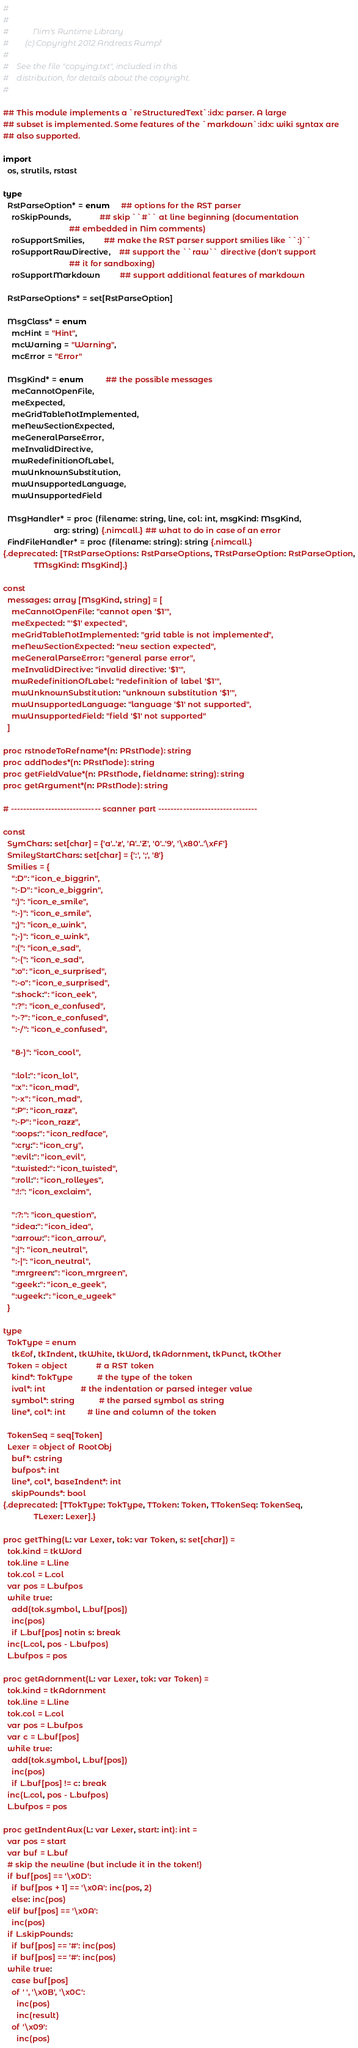<code> <loc_0><loc_0><loc_500><loc_500><_Nim_>#
#
#            Nim's Runtime Library
#        (c) Copyright 2012 Andreas Rumpf
#
#    See the file "copying.txt", included in this
#    distribution, for details about the copyright.
#

## This module implements a `reStructuredText`:idx: parser. A large
## subset is implemented. Some features of the `markdown`:idx: wiki syntax are
## also supported.

import
  os, strutils, rstast

type
  RstParseOption* = enum     ## options for the RST parser
    roSkipPounds,             ## skip ``#`` at line beginning (documentation
                              ## embedded in Nim comments)
    roSupportSmilies,         ## make the RST parser support smilies like ``:)``
    roSupportRawDirective,    ## support the ``raw`` directive (don't support
                              ## it for sandboxing)
    roSupportMarkdown         ## support additional features of markdown

  RstParseOptions* = set[RstParseOption]

  MsgClass* = enum
    mcHint = "Hint",
    mcWarning = "Warning",
    mcError = "Error"

  MsgKind* = enum          ## the possible messages
    meCannotOpenFile,
    meExpected,
    meGridTableNotImplemented,
    meNewSectionExpected,
    meGeneralParseError,
    meInvalidDirective,
    mwRedefinitionOfLabel,
    mwUnknownSubstitution,
    mwUnsupportedLanguage,
    mwUnsupportedField

  MsgHandler* = proc (filename: string, line, col: int, msgKind: MsgKind,
                       arg: string) {.nimcall.} ## what to do in case of an error
  FindFileHandler* = proc (filename: string): string {.nimcall.}
{.deprecated: [TRstParseOptions: RstParseOptions, TRstParseOption: RstParseOption,
              TMsgKind: MsgKind].}

const
  messages: array [MsgKind, string] = [
    meCannotOpenFile: "cannot open '$1'",
    meExpected: "'$1' expected",
    meGridTableNotImplemented: "grid table is not implemented",
    meNewSectionExpected: "new section expected",
    meGeneralParseError: "general parse error",
    meInvalidDirective: "invalid directive: '$1'",
    mwRedefinitionOfLabel: "redefinition of label '$1'",
    mwUnknownSubstitution: "unknown substitution '$1'",
    mwUnsupportedLanguage: "language '$1' not supported",
    mwUnsupportedField: "field '$1' not supported"
  ]

proc rstnodeToRefname*(n: PRstNode): string
proc addNodes*(n: PRstNode): string
proc getFieldValue*(n: PRstNode, fieldname: string): string
proc getArgument*(n: PRstNode): string

# ----------------------------- scanner part --------------------------------

const
  SymChars: set[char] = {'a'..'z', 'A'..'Z', '0'..'9', '\x80'..'\xFF'}
  SmileyStartChars: set[char] = {':', ';', '8'}
  Smilies = {
    ":D": "icon_e_biggrin",
    ":-D": "icon_e_biggrin",
    ":)": "icon_e_smile",
    ":-)": "icon_e_smile",
    ";)": "icon_e_wink",
    ";-)": "icon_e_wink",
    ":(": "icon_e_sad",
    ":-(": "icon_e_sad",
    ":o": "icon_e_surprised",
    ":-o": "icon_e_surprised",
    ":shock:": "icon_eek",
    ":?": "icon_e_confused",
    ":-?": "icon_e_confused",
    ":-/": "icon_e_confused",

    "8-)": "icon_cool",

    ":lol:": "icon_lol",
    ":x": "icon_mad",
    ":-x": "icon_mad",
    ":P": "icon_razz",
    ":-P": "icon_razz",
    ":oops:": "icon_redface",
    ":cry:": "icon_cry",
    ":evil:": "icon_evil",
    ":twisted:": "icon_twisted",
    ":roll:": "icon_rolleyes",
    ":!:": "icon_exclaim",

    ":?:": "icon_question",
    ":idea:": "icon_idea",
    ":arrow:": "icon_arrow",
    ":|": "icon_neutral",
    ":-|": "icon_neutral",
    ":mrgreen:": "icon_mrgreen",
    ":geek:": "icon_e_geek",
    ":ugeek:": "icon_e_ugeek"
  }

type
  TokType = enum
    tkEof, tkIndent, tkWhite, tkWord, tkAdornment, tkPunct, tkOther
  Token = object             # a RST token
    kind*: TokType           # the type of the token
    ival*: int                # the indentation or parsed integer value
    symbol*: string           # the parsed symbol as string
    line*, col*: int          # line and column of the token

  TokenSeq = seq[Token]
  Lexer = object of RootObj
    buf*: cstring
    bufpos*: int
    line*, col*, baseIndent*: int
    skipPounds*: bool
{.deprecated: [TTokType: TokType, TToken: Token, TTokenSeq: TokenSeq,
              TLexer: Lexer].}

proc getThing(L: var Lexer, tok: var Token, s: set[char]) =
  tok.kind = tkWord
  tok.line = L.line
  tok.col = L.col
  var pos = L.bufpos
  while true:
    add(tok.symbol, L.buf[pos])
    inc(pos)
    if L.buf[pos] notin s: break
  inc(L.col, pos - L.bufpos)
  L.bufpos = pos

proc getAdornment(L: var Lexer, tok: var Token) =
  tok.kind = tkAdornment
  tok.line = L.line
  tok.col = L.col
  var pos = L.bufpos
  var c = L.buf[pos]
  while true:
    add(tok.symbol, L.buf[pos])
    inc(pos)
    if L.buf[pos] != c: break
  inc(L.col, pos - L.bufpos)
  L.bufpos = pos

proc getIndentAux(L: var Lexer, start: int): int =
  var pos = start
  var buf = L.buf
  # skip the newline (but include it in the token!)
  if buf[pos] == '\x0D':
    if buf[pos + 1] == '\x0A': inc(pos, 2)
    else: inc(pos)
  elif buf[pos] == '\x0A':
    inc(pos)
  if L.skipPounds:
    if buf[pos] == '#': inc(pos)
    if buf[pos] == '#': inc(pos)
  while true:
    case buf[pos]
    of ' ', '\x0B', '\x0C':
      inc(pos)
      inc(result)
    of '\x09':
      inc(pos)</code> 